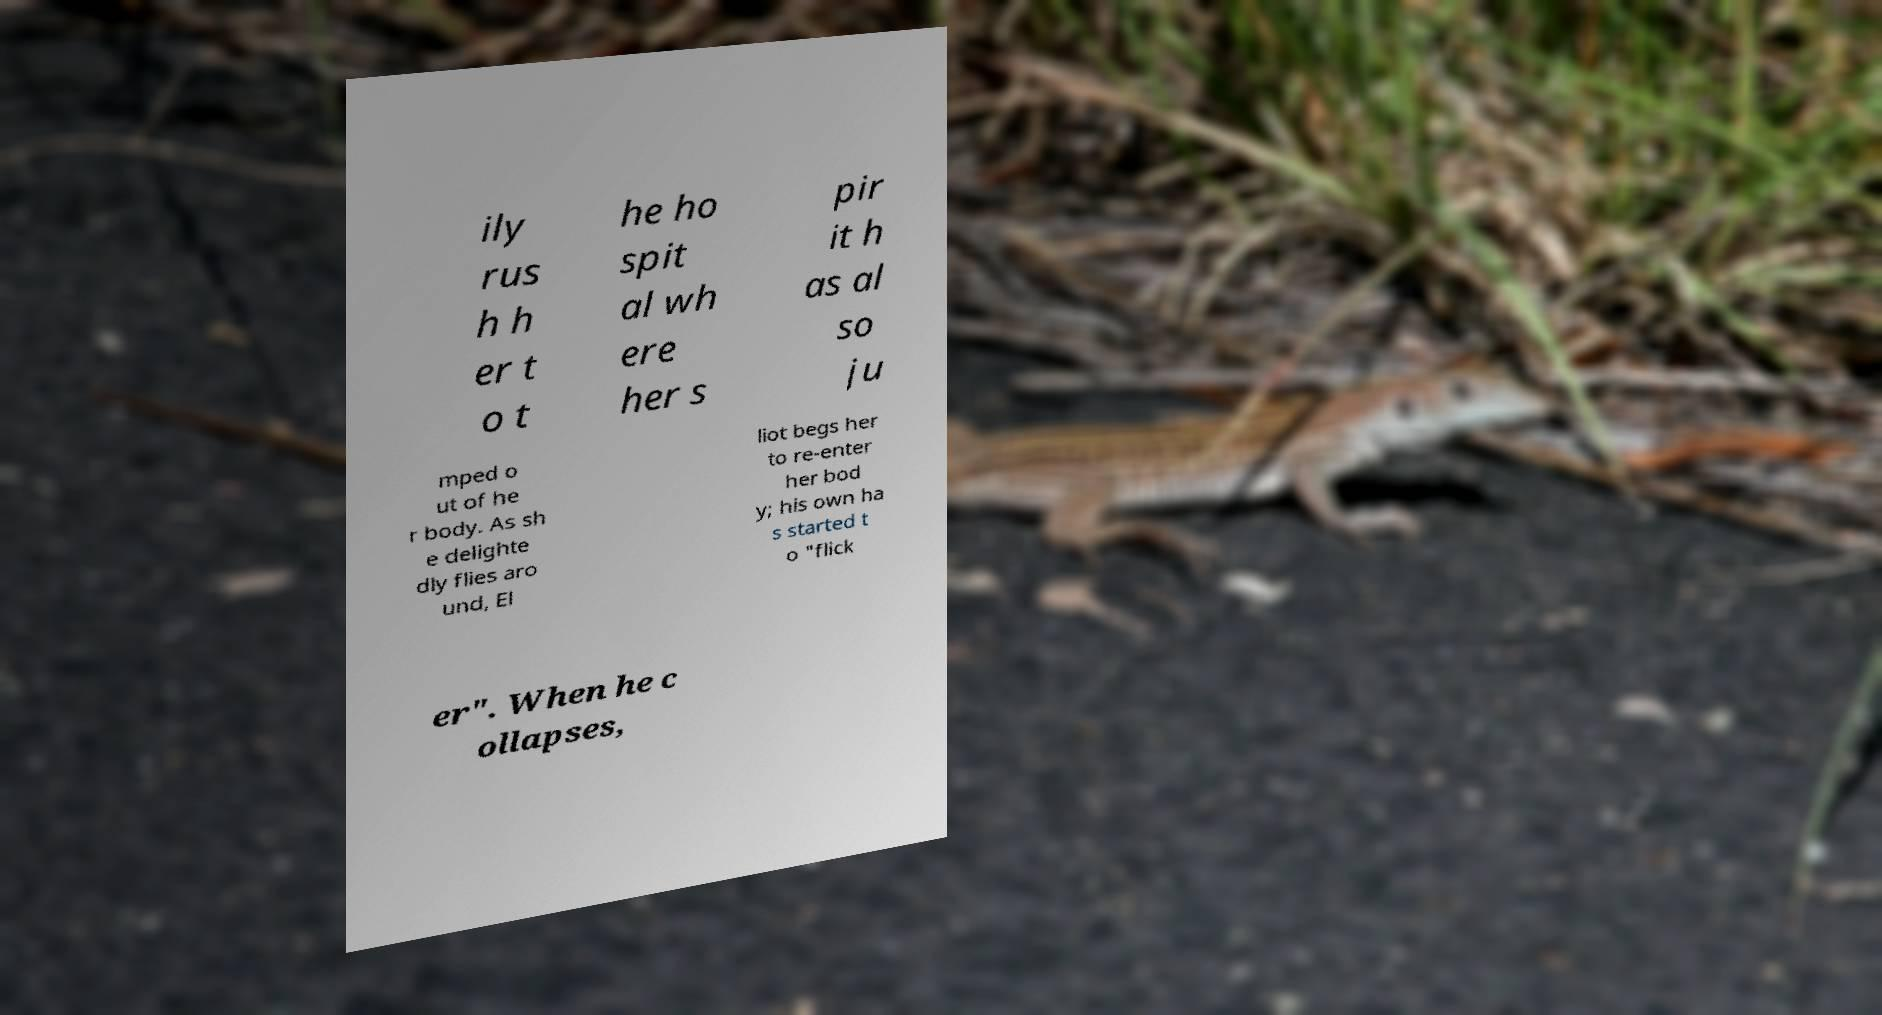Please read and relay the text visible in this image. What does it say? ily rus h h er t o t he ho spit al wh ere her s pir it h as al so ju mped o ut of he r body. As sh e delighte dly flies aro und, El liot begs her to re-enter her bod y; his own ha s started t o "flick er". When he c ollapses, 